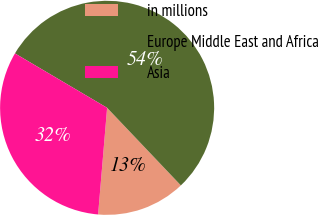Convert chart. <chart><loc_0><loc_0><loc_500><loc_500><pie_chart><fcel>in millions<fcel>Europe Middle East and Africa<fcel>Asia<nl><fcel>13.44%<fcel>54.42%<fcel>32.15%<nl></chart> 